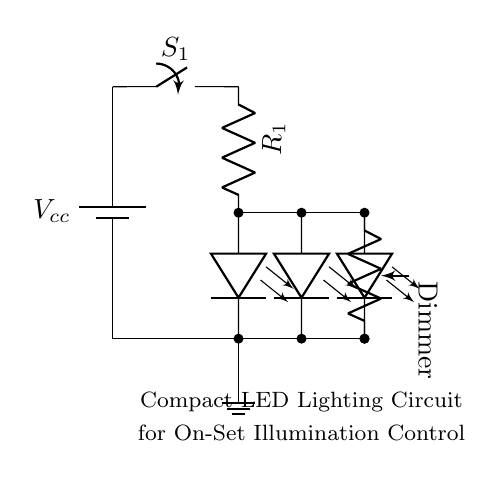What is the type of power supply used in this circuit? The circuit uses a battery as its power supply, indicated by the battery symbol labeled Vcc.
Answer: battery How many LEDs are in the circuit? There are three LED components represented, each labeled clearly in the circuit diagram.
Answer: three What is the purpose of resistor R1 in this circuit? Resistor R1 is a current limiting resistor, which is used to control the amount of current flowing through the LEDs to prevent damage.
Answer: current limiting What is the function of switch S1? Switch S1 acts as the main switch to control the flow of electricity to the rest of the circuit, allowing the user to turn the LEDs on or off.
Answer: on/off control What does the dimmer potentiometer do in the circuit? The dimmer potentiometer allows for the adjustment of the light intensity provided by the LED array, effectively controlling their brightness.
Answer: brightness control How are the LEDs connected in the circuit? The LEDs are connected in parallel, which allows each LED to operate independently while sharing the same voltage supply.
Answer: parallel What effect would removing resistor R1 have on the circuit? Removing resistor R1 would likely cause too much current to flow through the LEDs, risking their burnout or permanent damage.
Answer: LED damage 